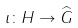<formula> <loc_0><loc_0><loc_500><loc_500>\iota \colon H \to { \widehat { G } }</formula> 